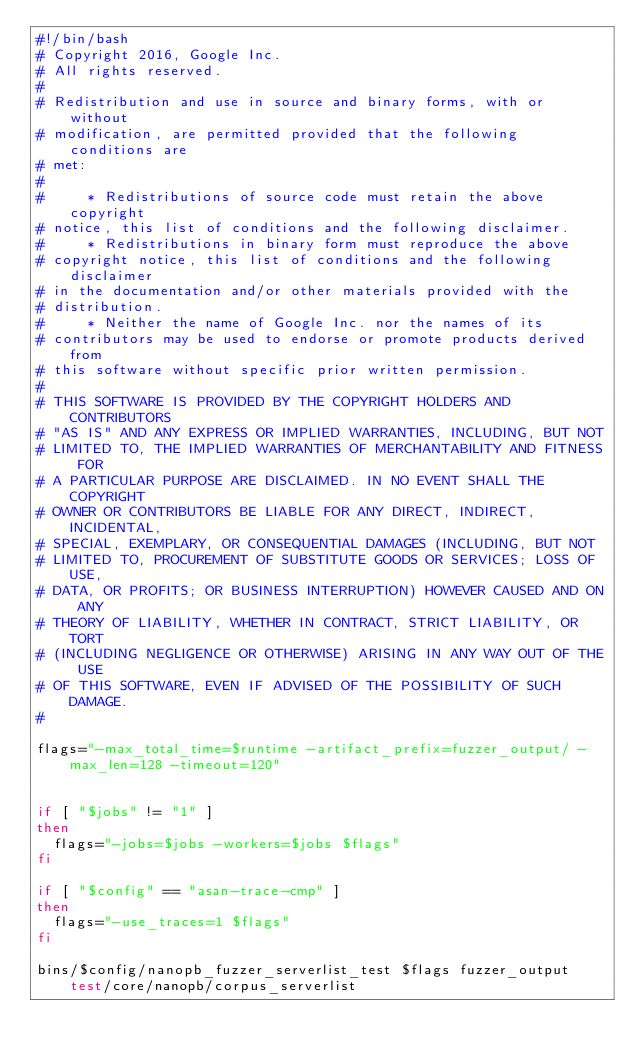<code> <loc_0><loc_0><loc_500><loc_500><_Bash_>#!/bin/bash
# Copyright 2016, Google Inc.
# All rights reserved.
#
# Redistribution and use in source and binary forms, with or without
# modification, are permitted provided that the following conditions are
# met:
#
#     * Redistributions of source code must retain the above copyright
# notice, this list of conditions and the following disclaimer.
#     * Redistributions in binary form must reproduce the above
# copyright notice, this list of conditions and the following disclaimer
# in the documentation and/or other materials provided with the
# distribution.
#     * Neither the name of Google Inc. nor the names of its
# contributors may be used to endorse or promote products derived from
# this software without specific prior written permission.
#
# THIS SOFTWARE IS PROVIDED BY THE COPYRIGHT HOLDERS AND CONTRIBUTORS
# "AS IS" AND ANY EXPRESS OR IMPLIED WARRANTIES, INCLUDING, BUT NOT
# LIMITED TO, THE IMPLIED WARRANTIES OF MERCHANTABILITY AND FITNESS FOR
# A PARTICULAR PURPOSE ARE DISCLAIMED. IN NO EVENT SHALL THE COPYRIGHT
# OWNER OR CONTRIBUTORS BE LIABLE FOR ANY DIRECT, INDIRECT, INCIDENTAL,
# SPECIAL, EXEMPLARY, OR CONSEQUENTIAL DAMAGES (INCLUDING, BUT NOT
# LIMITED TO, PROCUREMENT OF SUBSTITUTE GOODS OR SERVICES; LOSS OF USE,
# DATA, OR PROFITS; OR BUSINESS INTERRUPTION) HOWEVER CAUSED AND ON ANY
# THEORY OF LIABILITY, WHETHER IN CONTRACT, STRICT LIABILITY, OR TORT
# (INCLUDING NEGLIGENCE OR OTHERWISE) ARISING IN ANY WAY OUT OF THE USE
# OF THIS SOFTWARE, EVEN IF ADVISED OF THE POSSIBILITY OF SUCH DAMAGE.
#

flags="-max_total_time=$runtime -artifact_prefix=fuzzer_output/ -max_len=128 -timeout=120"


if [ "$jobs" != "1" ]
then
  flags="-jobs=$jobs -workers=$jobs $flags"
fi

if [ "$config" == "asan-trace-cmp" ]
then
  flags="-use_traces=1 $flags"
fi

bins/$config/nanopb_fuzzer_serverlist_test $flags fuzzer_output test/core/nanopb/corpus_serverlist
</code> 